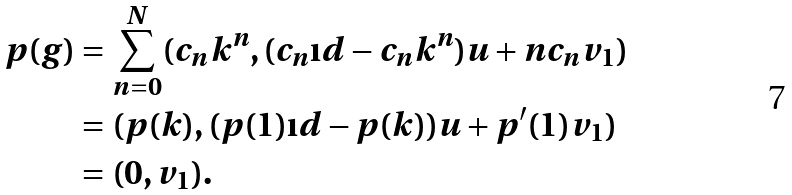<formula> <loc_0><loc_0><loc_500><loc_500>p ( g ) & = \sum _ { n = 0 } ^ { N } ( c _ { n } k ^ { n } , ( c _ { n } \i d - c _ { n } k ^ { n } ) u + n c _ { n } v _ { 1 } ) \\ & = ( p ( k ) , ( p ( 1 ) \i d - p ( k ) ) u + p ^ { \prime } ( 1 ) v _ { 1 } ) \\ & = ( 0 , v _ { 1 } ) .</formula> 